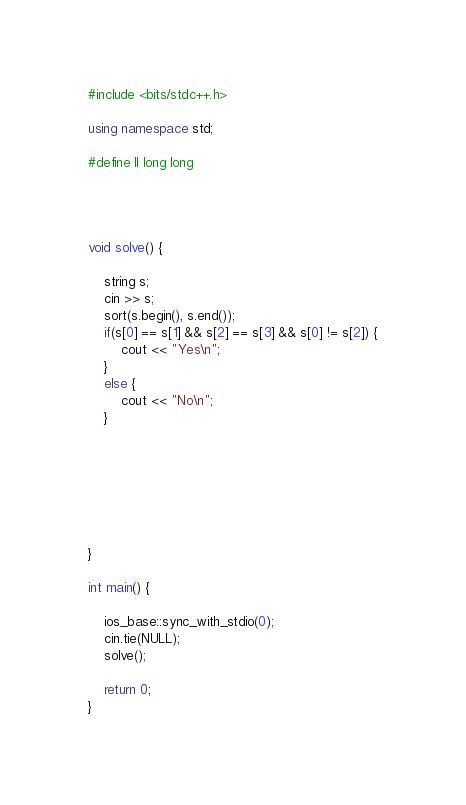Convert code to text. <code><loc_0><loc_0><loc_500><loc_500><_C++_>#include <bits/stdc++.h>

using namespace std;

#define ll long long




void solve() {

	string s;
	cin >> s;
	sort(s.begin(), s.end());
	if(s[0] == s[1] && s[2] == s[3] && s[0] != s[2]) {
		cout << "Yes\n";
	}
	else {
		cout << "No\n";
	}

	




	
}

int main() {

	ios_base::sync_with_stdio(0);
	cin.tie(NULL);
	solve();

	return 0;
}</code> 